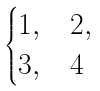<formula> <loc_0><loc_0><loc_500><loc_500>\begin{cases} 1 , & 2 , \\ 3 , & 4 \end{cases}</formula> 